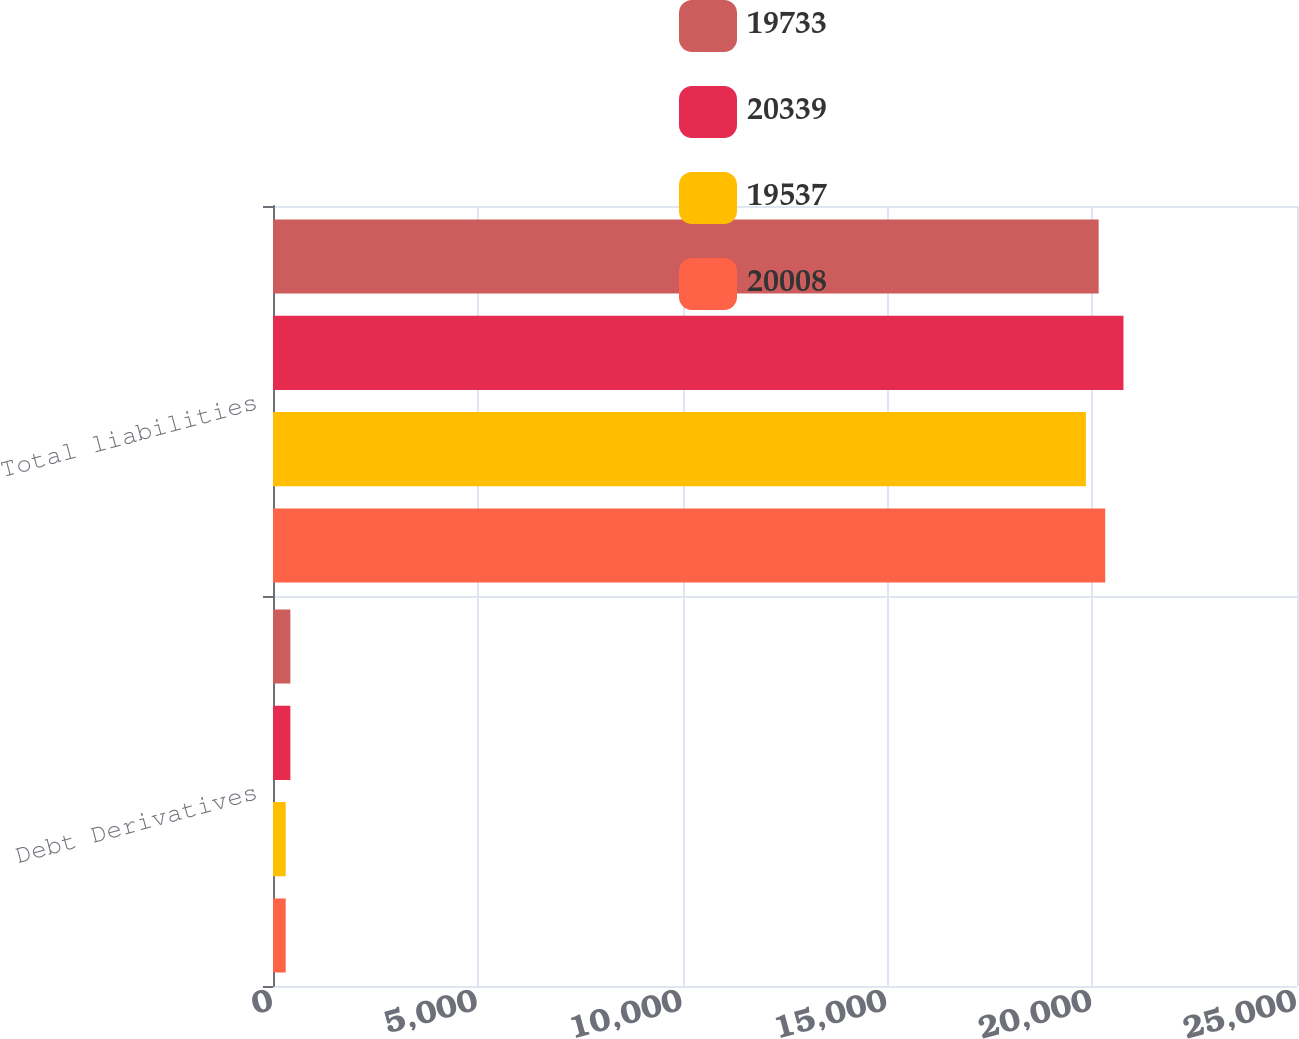Convert chart to OTSL. <chart><loc_0><loc_0><loc_500><loc_500><stacked_bar_chart><ecel><fcel>Debt Derivatives<fcel>Total liabilities<nl><fcel>19733<fcel>424<fcel>20157<nl><fcel>20339<fcel>424<fcel>20763<nl><fcel>19537<fcel>310<fcel>19847<nl><fcel>20008<fcel>310<fcel>20318<nl></chart> 